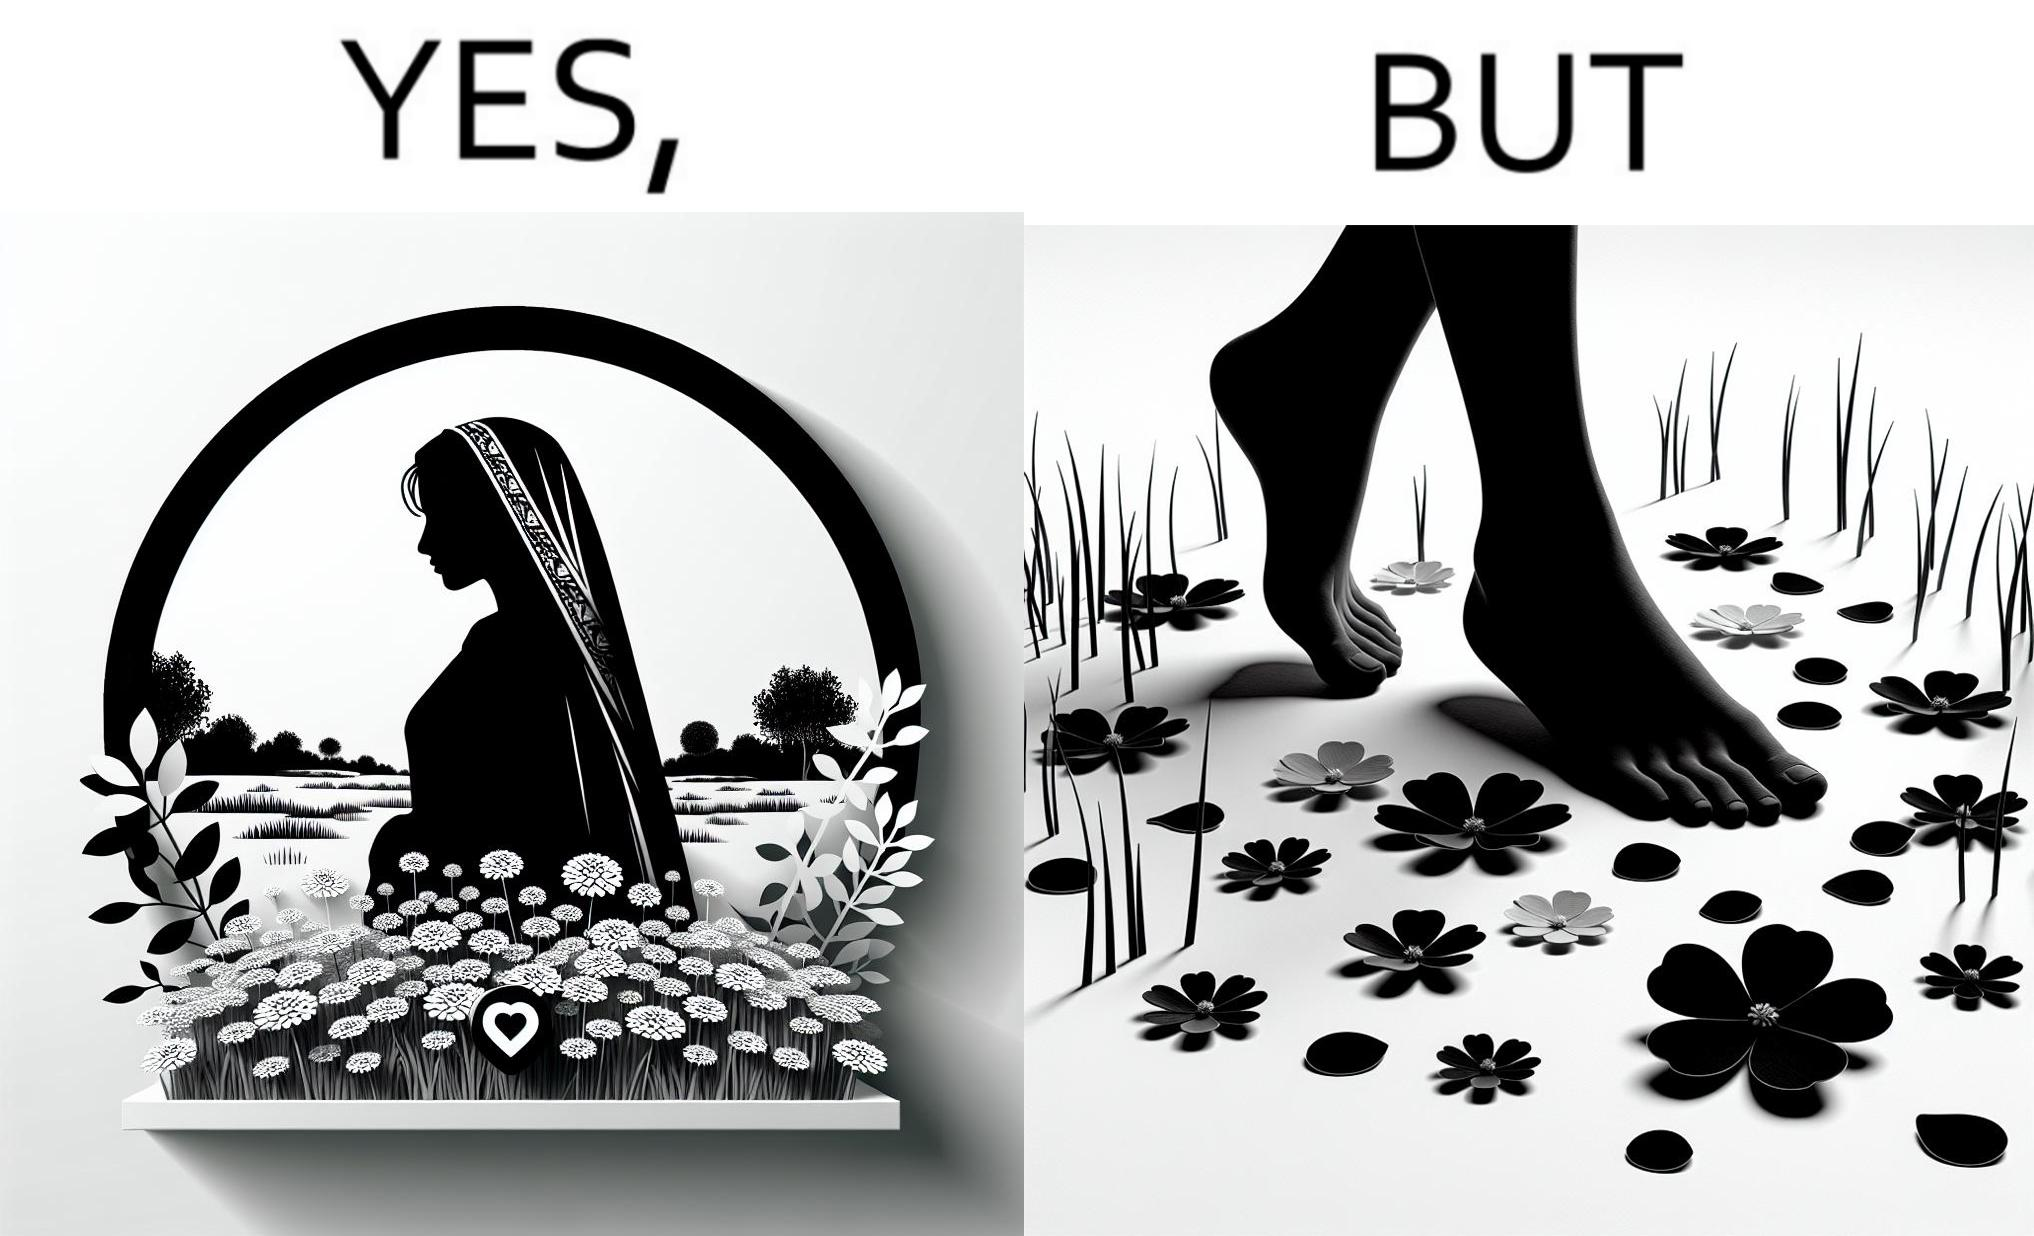Is this a satirical image? Yes, this image is satirical. 